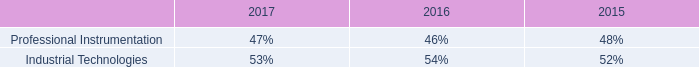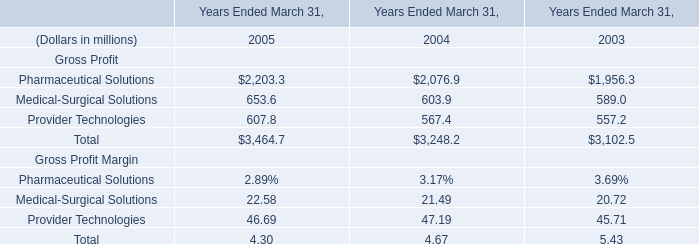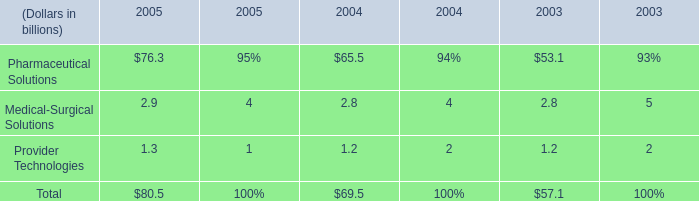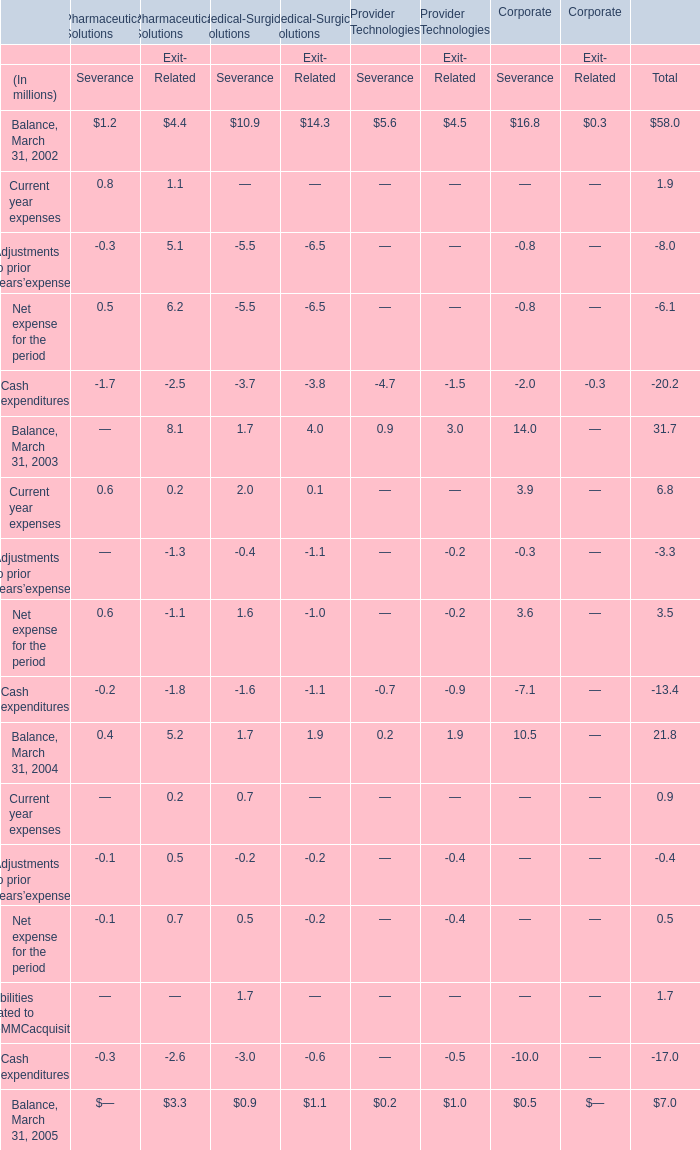What's the average of the Medical-Surgical Solutions in the years where Medical-Surgical Solutions is positive? (in million) 
Computations: (((653.6 + 603.9) + 589) / 3)
Answer: 615.5. 